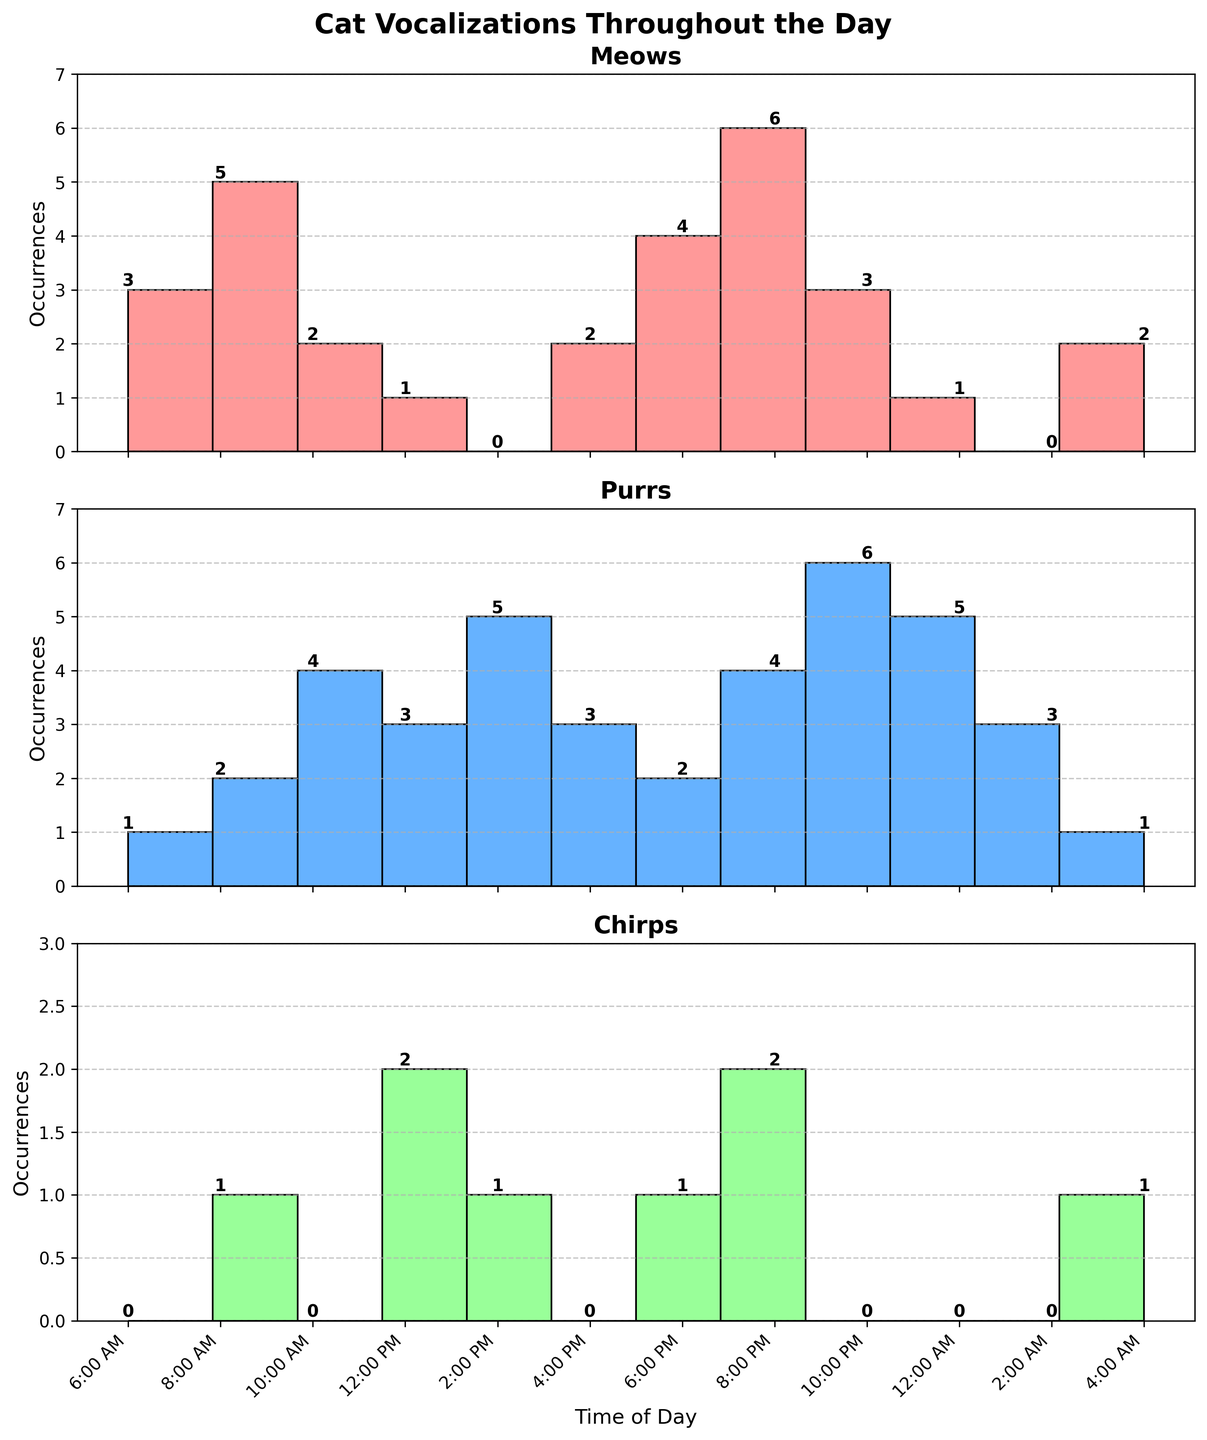What's the title of the figure? The title is displayed at the top of the figure in a larger and bold font style. It reads 'Cat Vocalizations Throughout the Day'.
Answer: Cat Vocalizations Throughout the Day At what time does the highest number of 'Meows' occur? By examining the 'Meows' subplot, the bar for 8:00 PM has the highest value with 6 occurrences.
Answer: 8:00 PM What is the total number of 'Purrs' vocalizations throughout the day? Add up all the occurrences of 'Purrs' from the subplot. The values are 1 + 2 + 4 + 3 + 5 + 3 + 2 + 4 + 6 + 5 + 3 + 1, which equals 39.
Answer: 39 How many times more 'Chirps' occurred at 12:00 PM compared to 6:00 AM? The occurrences of 'Chirps' at 12:00 PM and 6:00 AM are 2 and 0, respectively. Since dividing by zero isn't possible, the answer is simply that "Chirps" occurred 2 more times at 12:00 PM than at 6:00 AM.
Answer: 2 more times Compare the 'Meows' between 8:00 AM and 8:00 PM. Which time has a greater number and by how much? By examining the bars in the 'Meows' subplot at 8:00 AM and 8:00 PM, the values are 5 and 6, respectively. 8:00 PM has 6 - 5 = 1 more 'Meow' than 8:00 AM.
Answer: 8:00 PM, 1 more Which vocalization type has the most occurrences overall? Sum up the total occurrences for 'Meows', 'Purrs', and 'Chirps' respectively. Adding up: 'Meows' = 2 + 5 + 2 + 1 + 0 + 2 + 4 + 6 + 3 + 1 + 0 + 2 = 28, 'Purrs' = 39, 'Chirps' = 0 + 1 + 0 + 2 + 1 + 0 + 1 + 2 + 0 + 0 + 0 + 1 = 8. 'Purrs' have the highest total occurrences with 39.
Answer: Purrs What time of day shows the least overall vocalization activity? Add up the occurrences for all vocalization types at each time slot. The combined values are: 6:00 AM = 3, 8:00 AM = 8, 10:00 AM = 6, 12:00 PM = 6, 2:00 PM = 6, 4:00 PM = 5, 6:00 PM = 7, 8:00 PM = 12, 10:00 PM = 9, 12:00 AM = 6, 2:00 AM = 3, 4:00 AM = 4. The smallest total is 3 at 2:00 AM and 6:00 AM.
Answer: 2:00 AM and 6:00 AM How many occurrences of 'Meows' and 'Purrs' were recorded together at 10:00 PM? Looking at the subplots for 'Meows' and 'Purrs', 'Meows' at 10:00 PM is 3 and 'Purrs' is 6. Summing them gives 3 + 6 = 9.
Answer: 9 